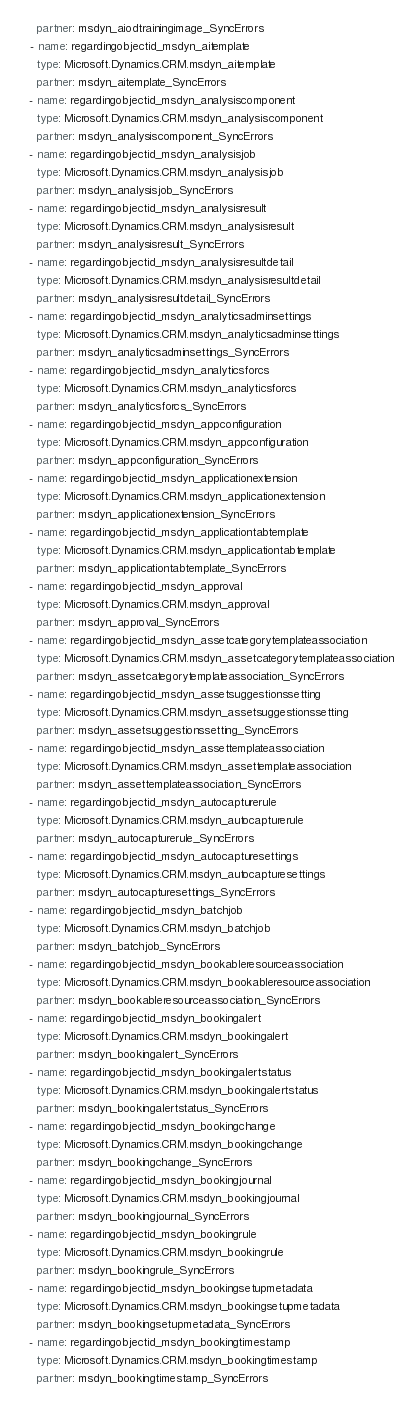Convert code to text. <code><loc_0><loc_0><loc_500><loc_500><_YAML_>    partner: msdyn_aiodtrainingimage_SyncErrors
  - name: regardingobjectid_msdyn_aitemplate
    type: Microsoft.Dynamics.CRM.msdyn_aitemplate
    partner: msdyn_aitemplate_SyncErrors
  - name: regardingobjectid_msdyn_analysiscomponent
    type: Microsoft.Dynamics.CRM.msdyn_analysiscomponent
    partner: msdyn_analysiscomponent_SyncErrors
  - name: regardingobjectid_msdyn_analysisjob
    type: Microsoft.Dynamics.CRM.msdyn_analysisjob
    partner: msdyn_analysisjob_SyncErrors
  - name: regardingobjectid_msdyn_analysisresult
    type: Microsoft.Dynamics.CRM.msdyn_analysisresult
    partner: msdyn_analysisresult_SyncErrors
  - name: regardingobjectid_msdyn_analysisresultdetail
    type: Microsoft.Dynamics.CRM.msdyn_analysisresultdetail
    partner: msdyn_analysisresultdetail_SyncErrors
  - name: regardingobjectid_msdyn_analyticsadminsettings
    type: Microsoft.Dynamics.CRM.msdyn_analyticsadminsettings
    partner: msdyn_analyticsadminsettings_SyncErrors
  - name: regardingobjectid_msdyn_analyticsforcs
    type: Microsoft.Dynamics.CRM.msdyn_analyticsforcs
    partner: msdyn_analyticsforcs_SyncErrors
  - name: regardingobjectid_msdyn_appconfiguration
    type: Microsoft.Dynamics.CRM.msdyn_appconfiguration
    partner: msdyn_appconfiguration_SyncErrors
  - name: regardingobjectid_msdyn_applicationextension
    type: Microsoft.Dynamics.CRM.msdyn_applicationextension
    partner: msdyn_applicationextension_SyncErrors
  - name: regardingobjectid_msdyn_applicationtabtemplate
    type: Microsoft.Dynamics.CRM.msdyn_applicationtabtemplate
    partner: msdyn_applicationtabtemplate_SyncErrors
  - name: regardingobjectid_msdyn_approval
    type: Microsoft.Dynamics.CRM.msdyn_approval
    partner: msdyn_approval_SyncErrors
  - name: regardingobjectid_msdyn_assetcategorytemplateassociation
    type: Microsoft.Dynamics.CRM.msdyn_assetcategorytemplateassociation
    partner: msdyn_assetcategorytemplateassociation_SyncErrors
  - name: regardingobjectid_msdyn_assetsuggestionssetting
    type: Microsoft.Dynamics.CRM.msdyn_assetsuggestionssetting
    partner: msdyn_assetsuggestionssetting_SyncErrors
  - name: regardingobjectid_msdyn_assettemplateassociation
    type: Microsoft.Dynamics.CRM.msdyn_assettemplateassociation
    partner: msdyn_assettemplateassociation_SyncErrors
  - name: regardingobjectid_msdyn_autocapturerule
    type: Microsoft.Dynamics.CRM.msdyn_autocapturerule
    partner: msdyn_autocapturerule_SyncErrors
  - name: regardingobjectid_msdyn_autocapturesettings
    type: Microsoft.Dynamics.CRM.msdyn_autocapturesettings
    partner: msdyn_autocapturesettings_SyncErrors
  - name: regardingobjectid_msdyn_batchjob
    type: Microsoft.Dynamics.CRM.msdyn_batchjob
    partner: msdyn_batchjob_SyncErrors
  - name: regardingobjectid_msdyn_bookableresourceassociation
    type: Microsoft.Dynamics.CRM.msdyn_bookableresourceassociation
    partner: msdyn_bookableresourceassociation_SyncErrors
  - name: regardingobjectid_msdyn_bookingalert
    type: Microsoft.Dynamics.CRM.msdyn_bookingalert
    partner: msdyn_bookingalert_SyncErrors
  - name: regardingobjectid_msdyn_bookingalertstatus
    type: Microsoft.Dynamics.CRM.msdyn_bookingalertstatus
    partner: msdyn_bookingalertstatus_SyncErrors
  - name: regardingobjectid_msdyn_bookingchange
    type: Microsoft.Dynamics.CRM.msdyn_bookingchange
    partner: msdyn_bookingchange_SyncErrors
  - name: regardingobjectid_msdyn_bookingjournal
    type: Microsoft.Dynamics.CRM.msdyn_bookingjournal
    partner: msdyn_bookingjournal_SyncErrors
  - name: regardingobjectid_msdyn_bookingrule
    type: Microsoft.Dynamics.CRM.msdyn_bookingrule
    partner: msdyn_bookingrule_SyncErrors
  - name: regardingobjectid_msdyn_bookingsetupmetadata
    type: Microsoft.Dynamics.CRM.msdyn_bookingsetupmetadata
    partner: msdyn_bookingsetupmetadata_SyncErrors
  - name: regardingobjectid_msdyn_bookingtimestamp
    type: Microsoft.Dynamics.CRM.msdyn_bookingtimestamp
    partner: msdyn_bookingtimestamp_SyncErrors</code> 